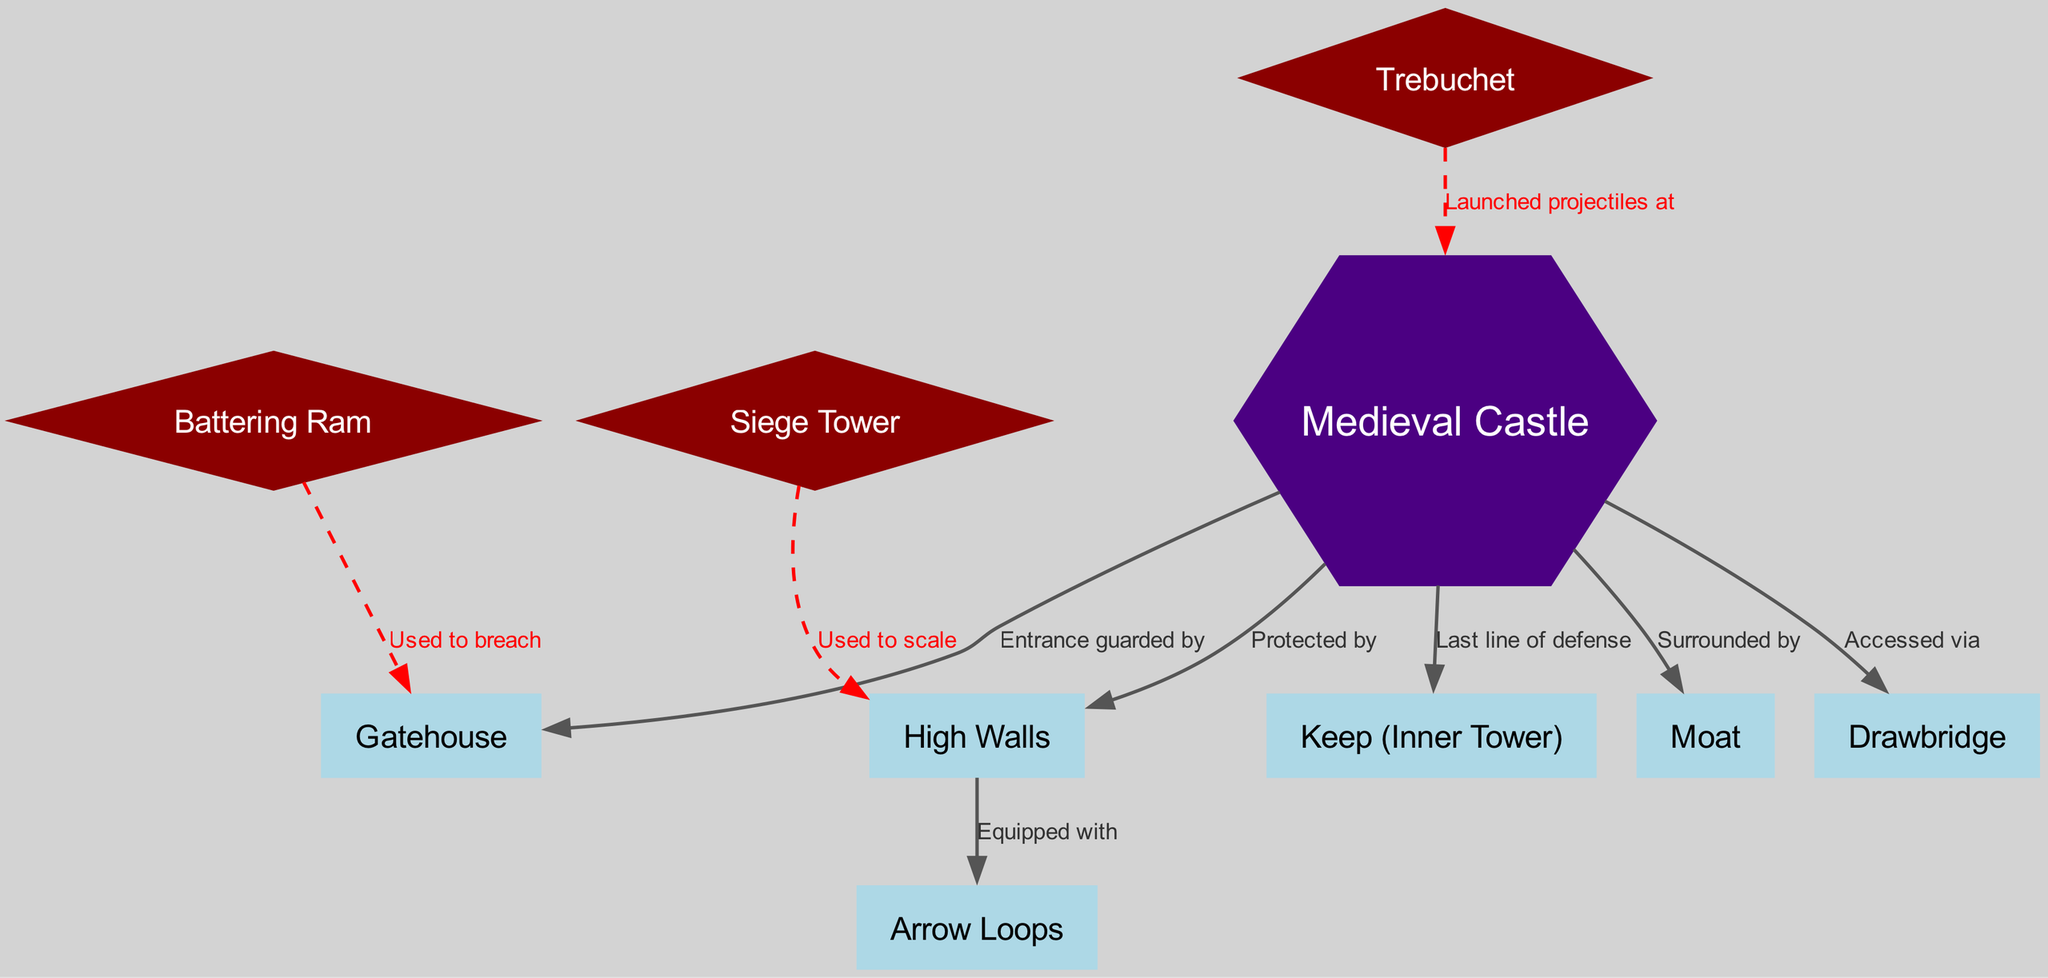What is the highest level of defense in the castle? The diagram indicates that the "Keep (Inner Tower)" is connected to the castle, tagged as the "Last line of defense." This implies that the keep serves as the primary stronghold or final defense point in the castle structure
Answer: Keep (Inner Tower) How many main nodes are present in the diagram? By counting the nodes listed in the data, there are a total of 10 nodes represented, indicating the various components of the castle and siege warfare tactics
Answer: 10 Which feature surrounds the castle? The diagram shows that the castle is connected to the "Moat" node, labeled as "Surrounded by." Therefore, this indicates that the moat serves as a protective barrier around the castle
Answer: Moat What is the purpose of the "Arrow Loops"? The relationship marked as "Equipped with" from the "High Walls" to the "Arrow Loops" indicates that the arrow loops are an integral part of the defensive strategy, allowing archers to shoot at attackers while minimizing exposure
Answer: Arrow Loops What is the function of the "Battering Ram"? The edge shows that the "Battering Ram" is used to breach the "Gatehouse." This indicates that the battering ram serves as an attacking tool employed during sieges to pound and break through gates, allowing access to the castle
Answer: Used to breach What is the connection between the "Siege Tower" and the "High Walls"? The diagram highlights that the "Siege Tower" is used to scale the "High Walls." This indicates that during a siege, attackers would employ siege towers to gain height advantage and overcome the castle walls
Answer: Used to scale What is the function of the "Trebuchet"? The diagram states that the "Trebuchet" is used to launch projectiles at the "Castle." This signifies that the trebuchet serves as a siege engine specifically designed to catapult objects and inflict damage from a distance
Answer: Launched projectiles at What is the mode of access to the castle? According to the diagram, the castle is accessed via the "Drawbridge." This implies that the drawbridge serves as the primary entry and exit point for individuals entering or leaving the castle
Answer: Drawbridge 